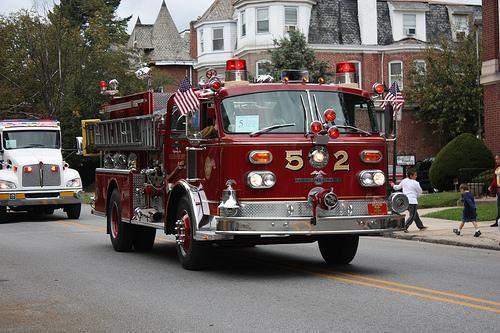How many trucks can be seen?
Give a very brief answer. 2. 